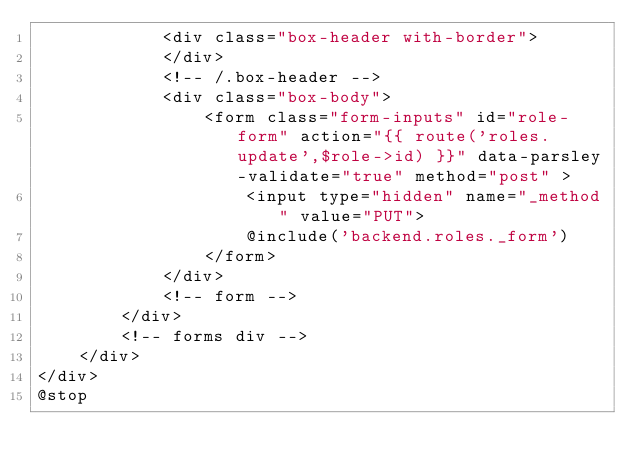<code> <loc_0><loc_0><loc_500><loc_500><_PHP_>			<div class="box-header with-border">
	        </div>
			<!-- /.box-header -->
			<div class="box-body">
				<form class="form-inputs" id="role-form" action="{{ route('roles.update',$role->id) }}" data-parsley-validate="true" method="post" >
					<input type="hidden" name="_method" value="PUT">
					@include('backend.roles._form')
				</form>
			</div>
			<!-- form -->
		</div>
		<!-- forms div -->
	</div>
</div>
@stop</code> 